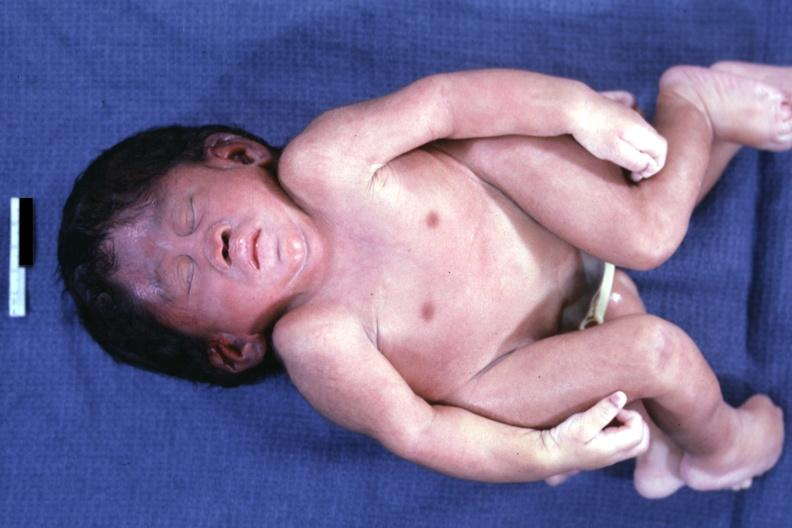s conjoined twins cephalothoracopagus janiceps present?
Answer the question using a single word or phrase. Yes 